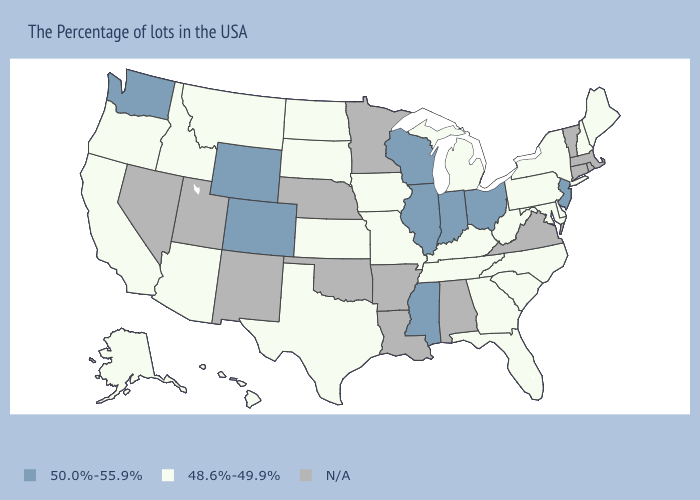What is the highest value in the USA?
Be succinct. 50.0%-55.9%. Does Ohio have the lowest value in the USA?
Keep it brief. No. What is the highest value in the USA?
Write a very short answer. 50.0%-55.9%. Name the states that have a value in the range 48.6%-49.9%?
Be succinct. Maine, New Hampshire, New York, Delaware, Maryland, Pennsylvania, North Carolina, South Carolina, West Virginia, Florida, Georgia, Michigan, Kentucky, Tennessee, Missouri, Iowa, Kansas, Texas, South Dakota, North Dakota, Montana, Arizona, Idaho, California, Oregon, Alaska, Hawaii. What is the value of Massachusetts?
Concise answer only. N/A. Name the states that have a value in the range N/A?
Write a very short answer. Massachusetts, Rhode Island, Vermont, Connecticut, Virginia, Alabama, Louisiana, Arkansas, Minnesota, Nebraska, Oklahoma, New Mexico, Utah, Nevada. Which states hav the highest value in the South?
Short answer required. Mississippi. What is the value of Missouri?
Short answer required. 48.6%-49.9%. Among the states that border Kansas , does Colorado have the highest value?
Quick response, please. Yes. Which states have the lowest value in the USA?
Write a very short answer. Maine, New Hampshire, New York, Delaware, Maryland, Pennsylvania, North Carolina, South Carolina, West Virginia, Florida, Georgia, Michigan, Kentucky, Tennessee, Missouri, Iowa, Kansas, Texas, South Dakota, North Dakota, Montana, Arizona, Idaho, California, Oregon, Alaska, Hawaii. Does California have the lowest value in the USA?
Quick response, please. Yes. Does Colorado have the highest value in the USA?
Keep it brief. Yes. What is the value of Arizona?
Keep it brief. 48.6%-49.9%. What is the highest value in states that border South Dakota?
Write a very short answer. 50.0%-55.9%. What is the value of Tennessee?
Be succinct. 48.6%-49.9%. 